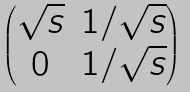Convert formula to latex. <formula><loc_0><loc_0><loc_500><loc_500>\begin{pmatrix} \sqrt { s } & { 1 } / { \sqrt { s } } \\ 0 & { 1 } / { \sqrt { s } } \end{pmatrix}</formula> 